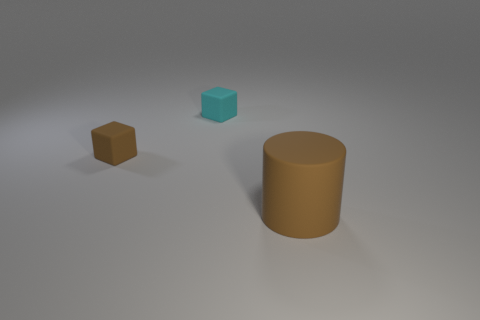Add 3 small matte blocks. How many objects exist? 6 Subtract all blocks. How many objects are left? 1 Subtract 1 brown cubes. How many objects are left? 2 Subtract all brown matte blocks. Subtract all small brown rubber cylinders. How many objects are left? 2 Add 2 tiny brown cubes. How many tiny brown cubes are left? 3 Add 3 large brown objects. How many large brown objects exist? 4 